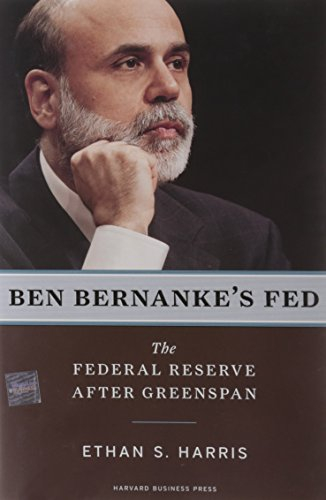Is this a financial book? Absolutely, this is a financial book that delves into the intricacies of the Federal Reserve system during Ben Bernanke's time at its helm, post-Alan Greenspan. 